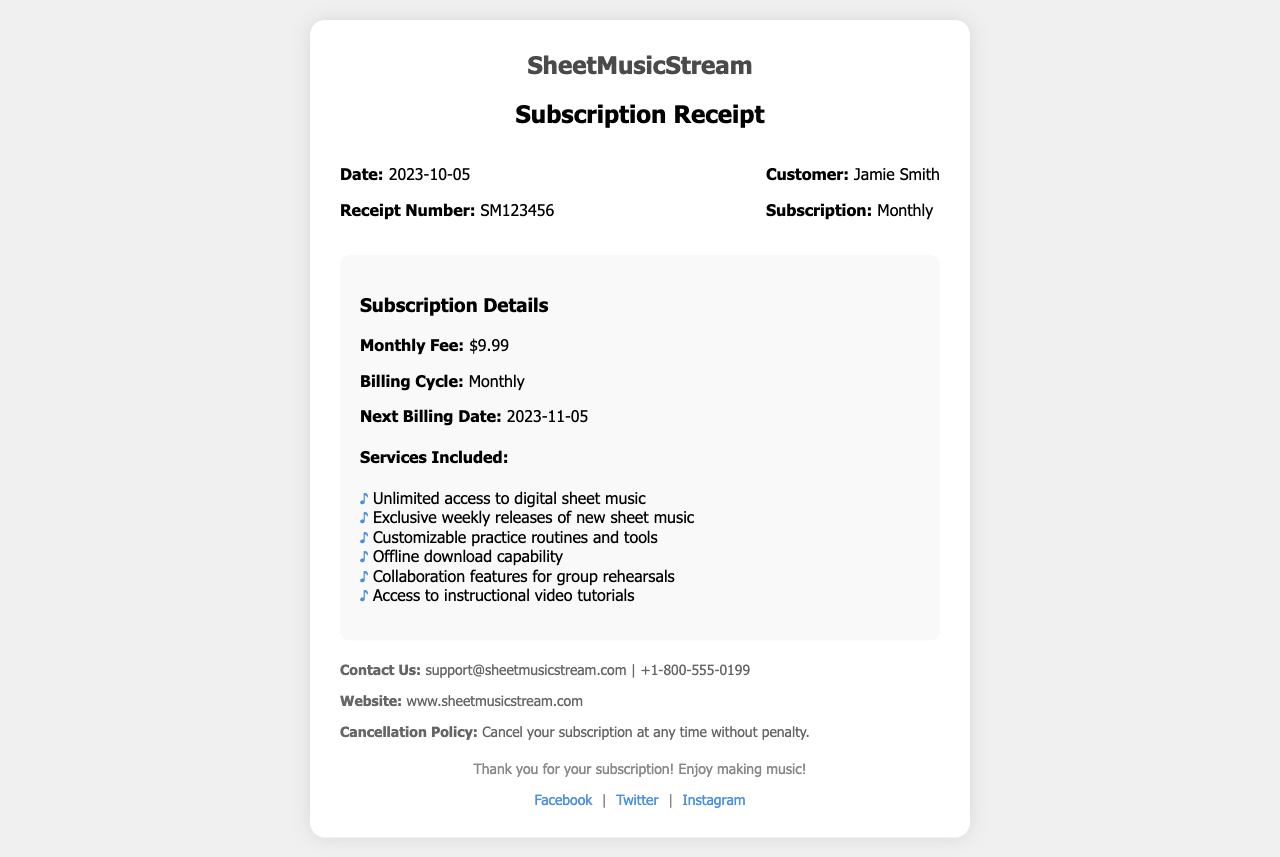What is the monthly fee? The monthly fee is stated directly in the subscription details section of the document.
Answer: $9.99 What is the receipt number? The receipt number is indicated in the receipt details section as a unique identifier for the transaction.
Answer: SM123456 Who is the customer? The customer's name is mentioned in the receipt details section, which identifies the individual associated with the subscription.
Answer: Jamie Smith What is the next billing date? The next billing date is provided in the subscription details to inform the customer of when they will be billed next.
Answer: 2023-11-05 What services are included in the subscription? The services included are listed in a bulleted format under the subscription details section to highlight the benefits of the subscription.
Answer: Unlimited access to digital sheet music, Exclusive weekly releases of new sheet music, Customizable practice routines and tools, Offline download capability, Collaboration features for group rehearsals, Access to instructional video tutorials What is the cancellation policy? The cancellation policy is included in the additional info section to inform the customer about their rights regarding the subscription.
Answer: Cancel your subscription at any time without penalty What company is this receipt for? The company name is presented prominently at the top of the receipt, identifying the service being subscribed to.
Answer: SheetMusicStream 